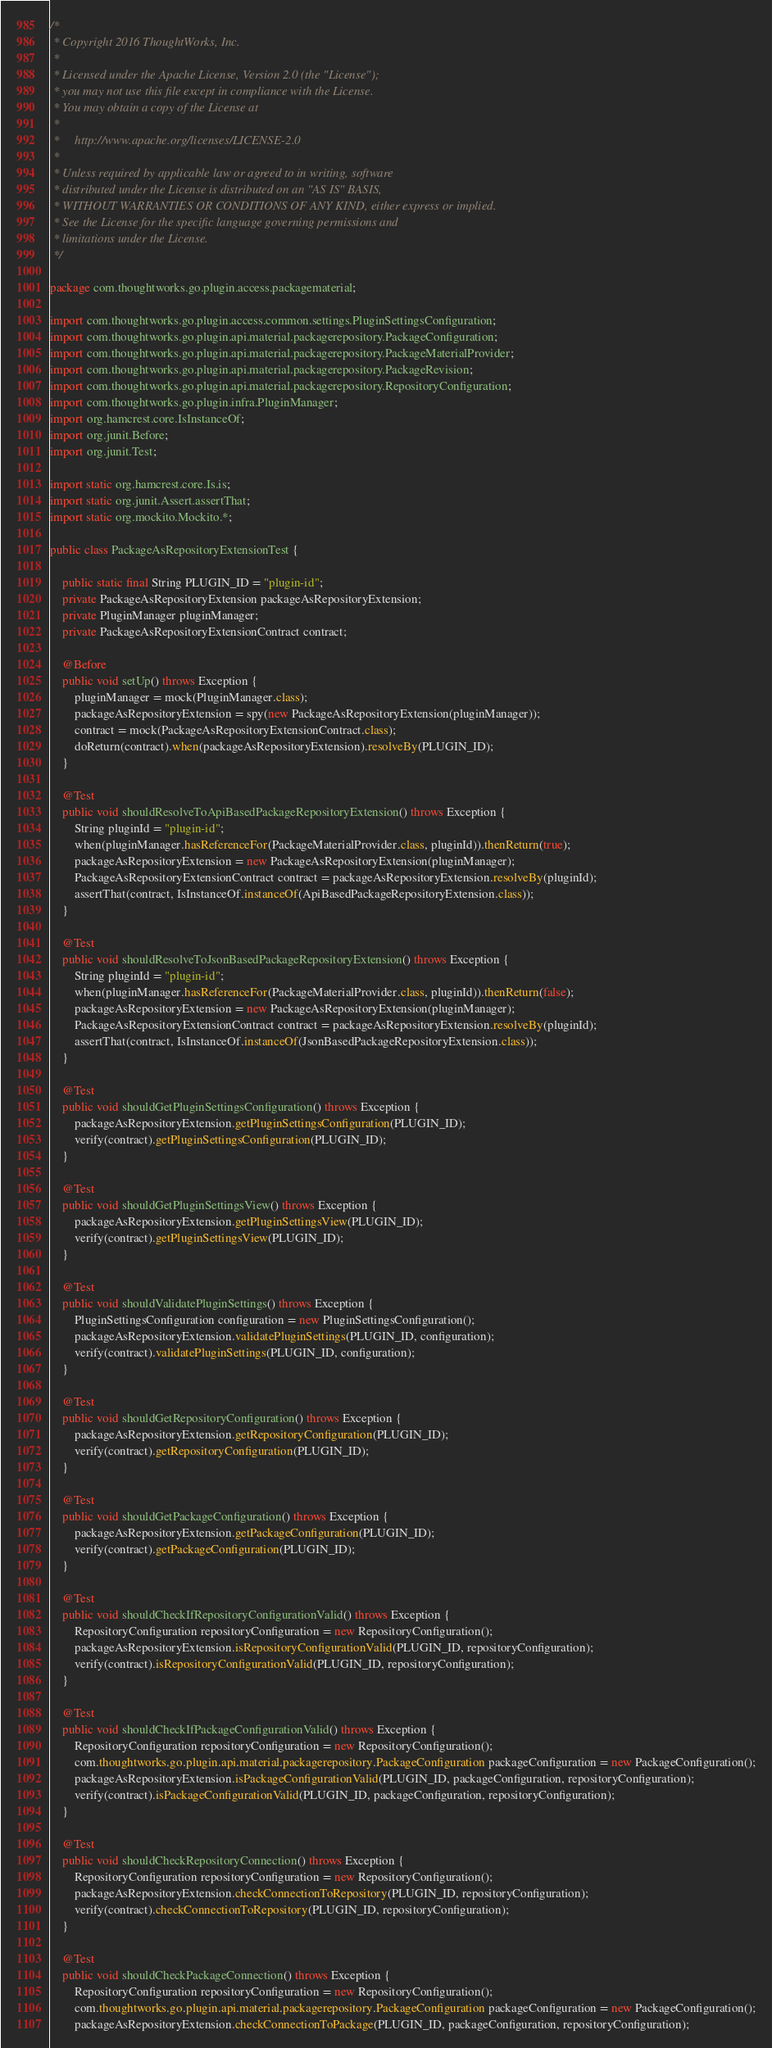<code> <loc_0><loc_0><loc_500><loc_500><_Java_>/*
 * Copyright 2016 ThoughtWorks, Inc.
 *
 * Licensed under the Apache License, Version 2.0 (the "License");
 * you may not use this file except in compliance with the License.
 * You may obtain a copy of the License at
 *
 *     http://www.apache.org/licenses/LICENSE-2.0
 *
 * Unless required by applicable law or agreed to in writing, software
 * distributed under the License is distributed on an "AS IS" BASIS,
 * WITHOUT WARRANTIES OR CONDITIONS OF ANY KIND, either express or implied.
 * See the License for the specific language governing permissions and
 * limitations under the License.
 */

package com.thoughtworks.go.plugin.access.packagematerial;

import com.thoughtworks.go.plugin.access.common.settings.PluginSettingsConfiguration;
import com.thoughtworks.go.plugin.api.material.packagerepository.PackageConfiguration;
import com.thoughtworks.go.plugin.api.material.packagerepository.PackageMaterialProvider;
import com.thoughtworks.go.plugin.api.material.packagerepository.PackageRevision;
import com.thoughtworks.go.plugin.api.material.packagerepository.RepositoryConfiguration;
import com.thoughtworks.go.plugin.infra.PluginManager;
import org.hamcrest.core.IsInstanceOf;
import org.junit.Before;
import org.junit.Test;

import static org.hamcrest.core.Is.is;
import static org.junit.Assert.assertThat;
import static org.mockito.Mockito.*;

public class PackageAsRepositoryExtensionTest {

    public static final String PLUGIN_ID = "plugin-id";
    private PackageAsRepositoryExtension packageAsRepositoryExtension;
    private PluginManager pluginManager;
    private PackageAsRepositoryExtensionContract contract;

    @Before
    public void setUp() throws Exception {
        pluginManager = mock(PluginManager.class);
        packageAsRepositoryExtension = spy(new PackageAsRepositoryExtension(pluginManager));
        contract = mock(PackageAsRepositoryExtensionContract.class);
        doReturn(contract).when(packageAsRepositoryExtension).resolveBy(PLUGIN_ID);
    }

    @Test
    public void shouldResolveToApiBasedPackageRepositoryExtension() throws Exception {
        String pluginId = "plugin-id";
        when(pluginManager.hasReferenceFor(PackageMaterialProvider.class, pluginId)).thenReturn(true);
        packageAsRepositoryExtension = new PackageAsRepositoryExtension(pluginManager);
        PackageAsRepositoryExtensionContract contract = packageAsRepositoryExtension.resolveBy(pluginId);
        assertThat(contract, IsInstanceOf.instanceOf(ApiBasedPackageRepositoryExtension.class));
    }

    @Test
    public void shouldResolveToJsonBasedPackageRepositoryExtension() throws Exception {
        String pluginId = "plugin-id";
        when(pluginManager.hasReferenceFor(PackageMaterialProvider.class, pluginId)).thenReturn(false);
        packageAsRepositoryExtension = new PackageAsRepositoryExtension(pluginManager);
        PackageAsRepositoryExtensionContract contract = packageAsRepositoryExtension.resolveBy(pluginId);
        assertThat(contract, IsInstanceOf.instanceOf(JsonBasedPackageRepositoryExtension.class));
    }

    @Test
    public void shouldGetPluginSettingsConfiguration() throws Exception {
        packageAsRepositoryExtension.getPluginSettingsConfiguration(PLUGIN_ID);
        verify(contract).getPluginSettingsConfiguration(PLUGIN_ID);
    }

    @Test
    public void shouldGetPluginSettingsView() throws Exception {
        packageAsRepositoryExtension.getPluginSettingsView(PLUGIN_ID);
        verify(contract).getPluginSettingsView(PLUGIN_ID);
    }

    @Test
    public void shouldValidatePluginSettings() throws Exception {
        PluginSettingsConfiguration configuration = new PluginSettingsConfiguration();
        packageAsRepositoryExtension.validatePluginSettings(PLUGIN_ID, configuration);
        verify(contract).validatePluginSettings(PLUGIN_ID, configuration);
    }

    @Test
    public void shouldGetRepositoryConfiguration() throws Exception {
        packageAsRepositoryExtension.getRepositoryConfiguration(PLUGIN_ID);
        verify(contract).getRepositoryConfiguration(PLUGIN_ID);
    }

    @Test
    public void shouldGetPackageConfiguration() throws Exception {
        packageAsRepositoryExtension.getPackageConfiguration(PLUGIN_ID);
        verify(contract).getPackageConfiguration(PLUGIN_ID);
    }

    @Test
    public void shouldCheckIfRepositoryConfigurationValid() throws Exception {
        RepositoryConfiguration repositoryConfiguration = new RepositoryConfiguration();
        packageAsRepositoryExtension.isRepositoryConfigurationValid(PLUGIN_ID, repositoryConfiguration);
        verify(contract).isRepositoryConfigurationValid(PLUGIN_ID, repositoryConfiguration);
    }

    @Test
    public void shouldCheckIfPackageConfigurationValid() throws Exception {
        RepositoryConfiguration repositoryConfiguration = new RepositoryConfiguration();
        com.thoughtworks.go.plugin.api.material.packagerepository.PackageConfiguration packageConfiguration = new PackageConfiguration();
        packageAsRepositoryExtension.isPackageConfigurationValid(PLUGIN_ID, packageConfiguration, repositoryConfiguration);
        verify(contract).isPackageConfigurationValid(PLUGIN_ID, packageConfiguration, repositoryConfiguration);
    }

    @Test
    public void shouldCheckRepositoryConnection() throws Exception {
        RepositoryConfiguration repositoryConfiguration = new RepositoryConfiguration();
        packageAsRepositoryExtension.checkConnectionToRepository(PLUGIN_ID, repositoryConfiguration);
        verify(contract).checkConnectionToRepository(PLUGIN_ID, repositoryConfiguration);
    }

    @Test
    public void shouldCheckPackageConnection() throws Exception {
        RepositoryConfiguration repositoryConfiguration = new RepositoryConfiguration();
        com.thoughtworks.go.plugin.api.material.packagerepository.PackageConfiguration packageConfiguration = new PackageConfiguration();
        packageAsRepositoryExtension.checkConnectionToPackage(PLUGIN_ID, packageConfiguration, repositoryConfiguration);</code> 